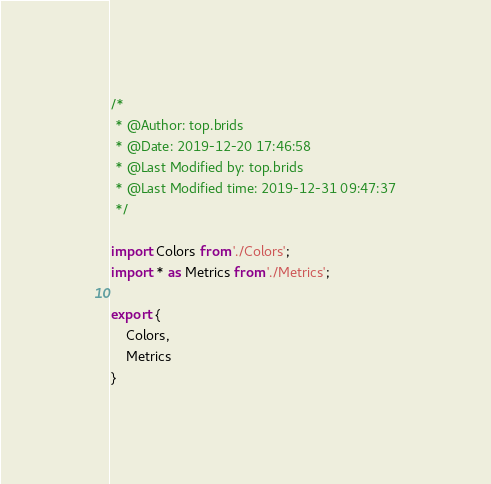Convert code to text. <code><loc_0><loc_0><loc_500><loc_500><_JavaScript_>/*
 * @Author: top.brids 
 * @Date: 2019-12-20 17:46:58 
 * @Last Modified by: top.brids
 * @Last Modified time: 2019-12-31 09:47:37
 */

import Colors from './Colors';
import * as Metrics from './Metrics';

export {
    Colors,
    Metrics
}</code> 